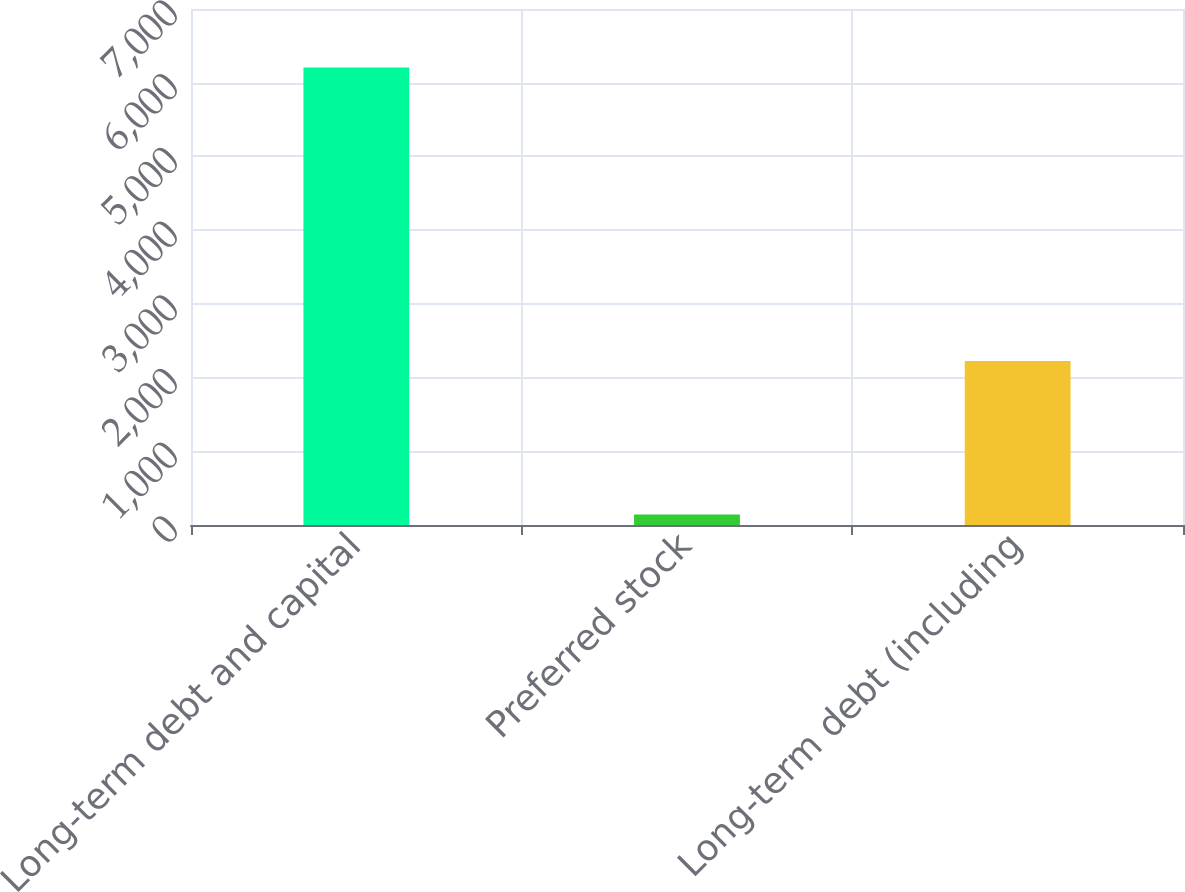<chart> <loc_0><loc_0><loc_500><loc_500><bar_chart><fcel>Long-term debt and capital<fcel>Preferred stock<fcel>Long-term debt (including<nl><fcel>6205<fcel>142<fcel>2224<nl></chart> 